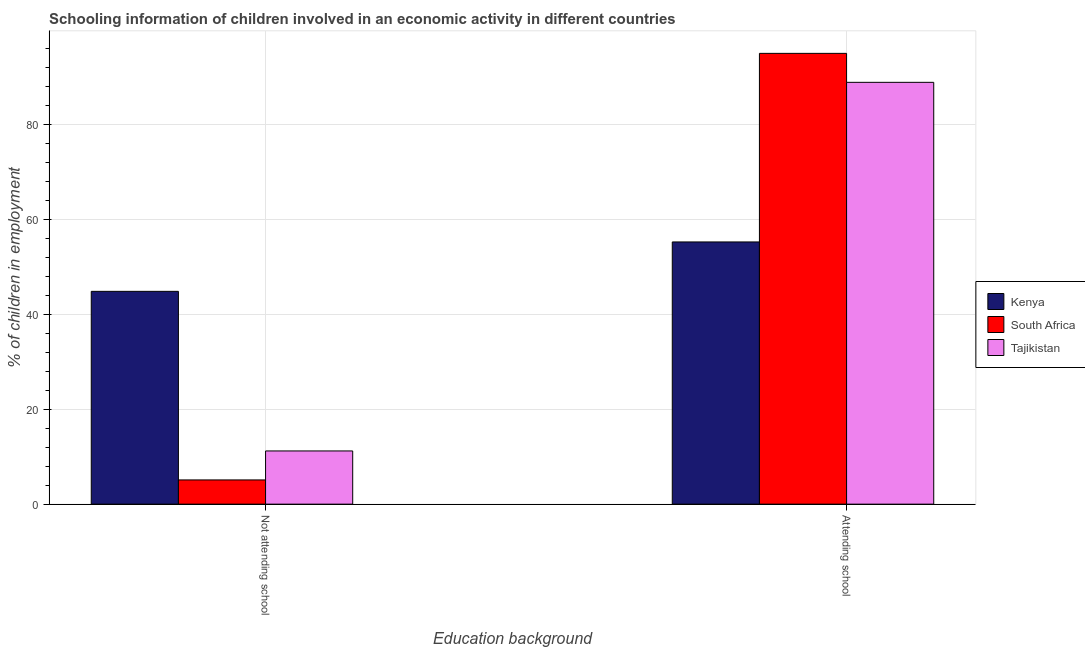How many different coloured bars are there?
Provide a succinct answer. 3. Are the number of bars per tick equal to the number of legend labels?
Provide a succinct answer. Yes. How many bars are there on the 1st tick from the left?
Your answer should be compact. 3. How many bars are there on the 1st tick from the right?
Provide a succinct answer. 3. What is the label of the 2nd group of bars from the left?
Ensure brevity in your answer.  Attending school. What is the percentage of employed children who are attending school in Kenya?
Your response must be concise. 55.2. Across all countries, what is the maximum percentage of employed children who are attending school?
Make the answer very short. 94.9. Across all countries, what is the minimum percentage of employed children who are attending school?
Your answer should be very brief. 55.2. In which country was the percentage of employed children who are not attending school maximum?
Offer a very short reply. Kenya. In which country was the percentage of employed children who are not attending school minimum?
Your answer should be very brief. South Africa. What is the total percentage of employed children who are not attending school in the graph?
Ensure brevity in your answer.  61.1. What is the difference between the percentage of employed children who are attending school in Kenya and that in South Africa?
Give a very brief answer. -39.7. What is the difference between the percentage of employed children who are not attending school in Kenya and the percentage of employed children who are attending school in South Africa?
Provide a short and direct response. -50.1. What is the average percentage of employed children who are not attending school per country?
Your answer should be very brief. 20.37. What is the difference between the percentage of employed children who are not attending school and percentage of employed children who are attending school in Tajikistan?
Offer a very short reply. -77.6. In how many countries, is the percentage of employed children who are not attending school greater than 4 %?
Give a very brief answer. 3. What is the ratio of the percentage of employed children who are not attending school in South Africa to that in Kenya?
Make the answer very short. 0.11. Is the percentage of employed children who are not attending school in South Africa less than that in Tajikistan?
Keep it short and to the point. Yes. In how many countries, is the percentage of employed children who are attending school greater than the average percentage of employed children who are attending school taken over all countries?
Ensure brevity in your answer.  2. What does the 2nd bar from the left in Not attending school represents?
Give a very brief answer. South Africa. What does the 2nd bar from the right in Attending school represents?
Keep it short and to the point. South Africa. How many bars are there?
Your answer should be compact. 6. How many countries are there in the graph?
Your response must be concise. 3. Does the graph contain grids?
Give a very brief answer. Yes. How many legend labels are there?
Your answer should be very brief. 3. How are the legend labels stacked?
Your answer should be compact. Vertical. What is the title of the graph?
Keep it short and to the point. Schooling information of children involved in an economic activity in different countries. What is the label or title of the X-axis?
Your answer should be compact. Education background. What is the label or title of the Y-axis?
Provide a succinct answer. % of children in employment. What is the % of children in employment in Kenya in Not attending school?
Provide a short and direct response. 44.8. What is the % of children in employment in Tajikistan in Not attending school?
Keep it short and to the point. 11.2. What is the % of children in employment in Kenya in Attending school?
Your answer should be compact. 55.2. What is the % of children in employment of South Africa in Attending school?
Ensure brevity in your answer.  94.9. What is the % of children in employment of Tajikistan in Attending school?
Offer a very short reply. 88.8. Across all Education background, what is the maximum % of children in employment of Kenya?
Offer a very short reply. 55.2. Across all Education background, what is the maximum % of children in employment in South Africa?
Offer a terse response. 94.9. Across all Education background, what is the maximum % of children in employment of Tajikistan?
Offer a terse response. 88.8. Across all Education background, what is the minimum % of children in employment in Kenya?
Keep it short and to the point. 44.8. Across all Education background, what is the minimum % of children in employment in Tajikistan?
Keep it short and to the point. 11.2. What is the total % of children in employment in Kenya in the graph?
Provide a short and direct response. 100. What is the total % of children in employment of Tajikistan in the graph?
Provide a short and direct response. 100. What is the difference between the % of children in employment of Kenya in Not attending school and that in Attending school?
Your answer should be compact. -10.4. What is the difference between the % of children in employment of South Africa in Not attending school and that in Attending school?
Your response must be concise. -89.8. What is the difference between the % of children in employment in Tajikistan in Not attending school and that in Attending school?
Give a very brief answer. -77.6. What is the difference between the % of children in employment in Kenya in Not attending school and the % of children in employment in South Africa in Attending school?
Offer a terse response. -50.1. What is the difference between the % of children in employment of Kenya in Not attending school and the % of children in employment of Tajikistan in Attending school?
Give a very brief answer. -44. What is the difference between the % of children in employment in South Africa in Not attending school and the % of children in employment in Tajikistan in Attending school?
Your answer should be compact. -83.7. What is the average % of children in employment in South Africa per Education background?
Your answer should be very brief. 50. What is the difference between the % of children in employment of Kenya and % of children in employment of South Africa in Not attending school?
Give a very brief answer. 39.7. What is the difference between the % of children in employment in Kenya and % of children in employment in Tajikistan in Not attending school?
Provide a succinct answer. 33.6. What is the difference between the % of children in employment of Kenya and % of children in employment of South Africa in Attending school?
Your response must be concise. -39.7. What is the difference between the % of children in employment of Kenya and % of children in employment of Tajikistan in Attending school?
Provide a short and direct response. -33.6. What is the difference between the % of children in employment in South Africa and % of children in employment in Tajikistan in Attending school?
Make the answer very short. 6.1. What is the ratio of the % of children in employment in Kenya in Not attending school to that in Attending school?
Ensure brevity in your answer.  0.81. What is the ratio of the % of children in employment in South Africa in Not attending school to that in Attending school?
Provide a short and direct response. 0.05. What is the ratio of the % of children in employment in Tajikistan in Not attending school to that in Attending school?
Give a very brief answer. 0.13. What is the difference between the highest and the second highest % of children in employment of Kenya?
Provide a short and direct response. 10.4. What is the difference between the highest and the second highest % of children in employment in South Africa?
Keep it short and to the point. 89.8. What is the difference between the highest and the second highest % of children in employment of Tajikistan?
Offer a very short reply. 77.6. What is the difference between the highest and the lowest % of children in employment of Kenya?
Your answer should be compact. 10.4. What is the difference between the highest and the lowest % of children in employment in South Africa?
Provide a short and direct response. 89.8. What is the difference between the highest and the lowest % of children in employment in Tajikistan?
Offer a terse response. 77.6. 